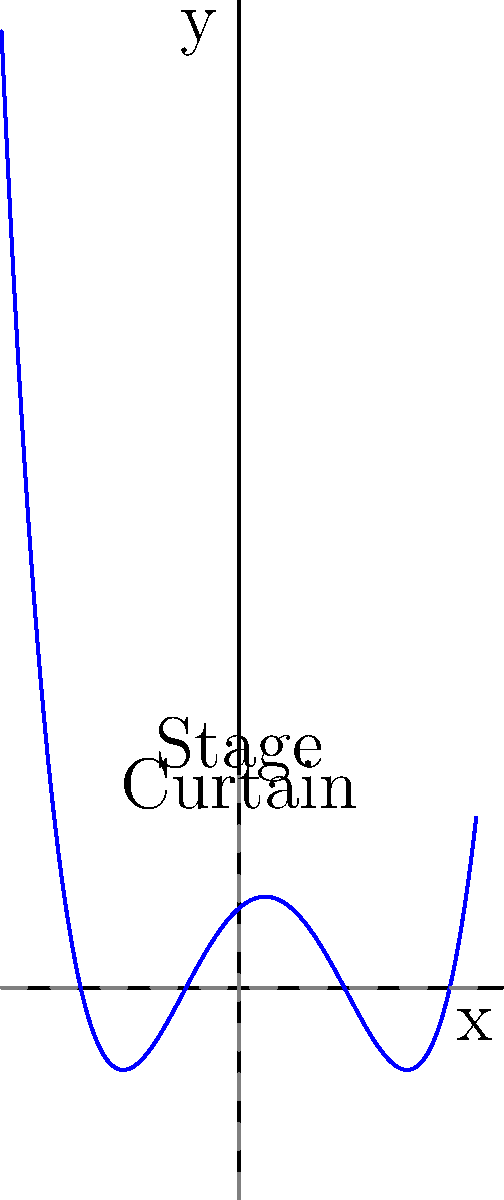In the theatrical world of polynomials, we have a stage curtain represented by the graph of a polynomial function. As an actor, you need to determine the exact moments when the curtain touches the stage floor. Given the graph resembling an opening stage curtain, find the roots of the polynomial function. What are the x-coordinates where the function intersects the x-axis? To find the roots of this polynomial function, we need to identify where the graph crosses the x-axis. Let's approach this step-by-step:

1) Observe the graph carefully. The roots are the x-intercepts, where y = 0.

2) Count the number of times the graph crosses the x-axis. In this case, we can see 4 intersections.

3) Estimate the x-coordinates of these intersections:
   - The leftmost root appears to be at x = -3
   - The next root is close to x = -1
   - The third root is at x = 2
   - The rightmost root is at x = 4

4) These x-values represent the roots of the polynomial function.

5) In terms of our stage curtain analogy:
   - x = -3 and x = 4 represent the edges of the curtain touching the stage
   - x = -1 and x = 2 represent the inner folds of the curtain touching the stage

Therefore, the roots of this polynomial function are x = -3, x = -1, x = 2, and x = 4.
Answer: $x = -3, -1, 2, 4$ 